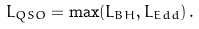<formula> <loc_0><loc_0><loc_500><loc_500>L _ { Q S O } = \max ( L _ { B H } , L _ { E d d } ) \, .</formula> 